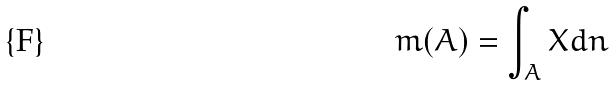Convert formula to latex. <formula><loc_0><loc_0><loc_500><loc_500>m ( A ) = \int _ { A } X d n</formula> 